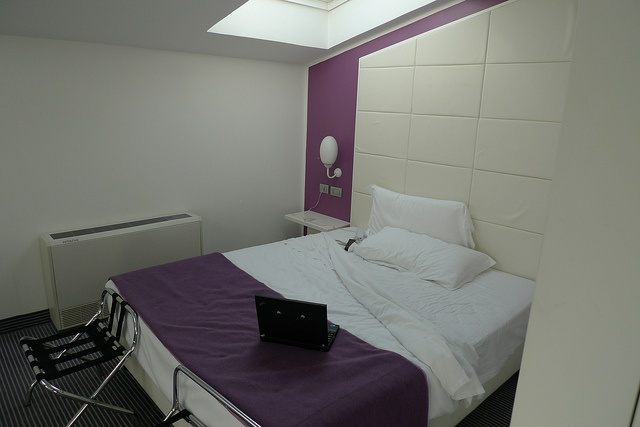Describe the objects in this image and their specific colors. I can see bed in gray, darkgray, and black tones, chair in gray and black tones, laptop in gray, black, darkgray, and purple tones, and chair in gray and black tones in this image. 